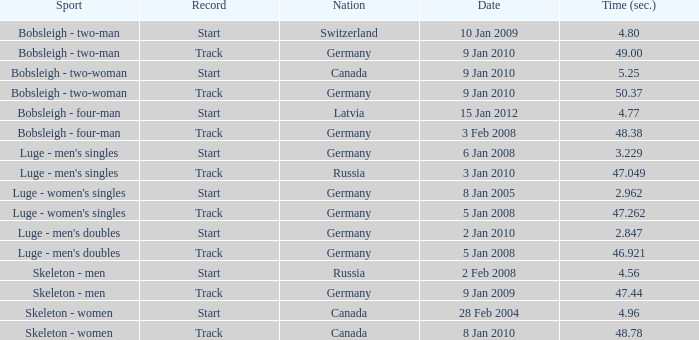Which nation recorded a time of 4 Germany. 